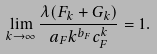Convert formula to latex. <formula><loc_0><loc_0><loc_500><loc_500>\lim _ { k \to \infty } \frac { \lambda ( F _ { k } + G _ { k } ) } { a _ { F } k ^ { b _ { F } } c _ { F } ^ { k } } = 1 .</formula> 